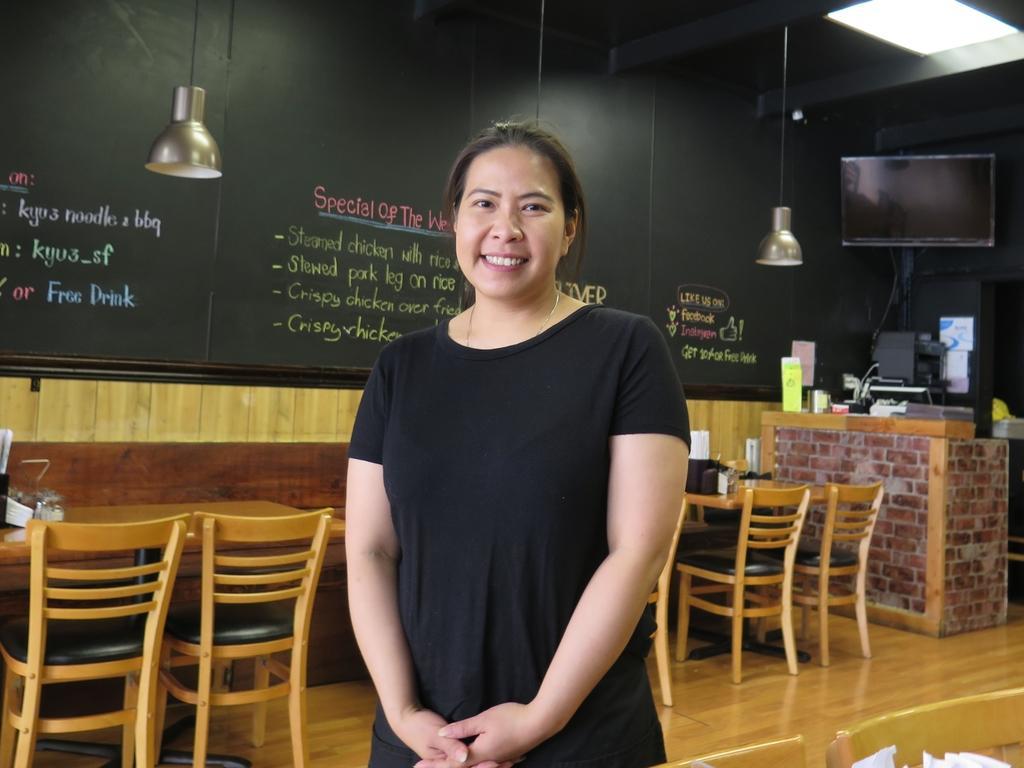How would you summarize this image in a sentence or two? In this picture we can see a woman standing and smiling, tables, chairs and in the background we can see a television, lamps and some objects. 